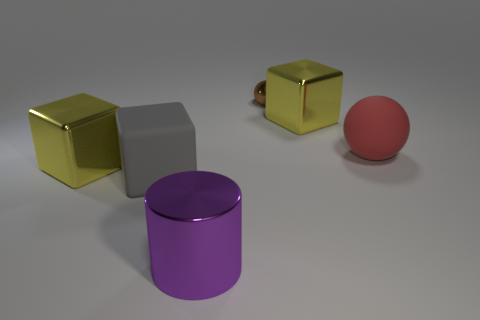Subtract all yellow blocks. How many were subtracted if there are1yellow blocks left? 1 Subtract all shiny blocks. How many blocks are left? 1 Add 2 large brown cylinders. How many objects exist? 8 Subtract all gray cubes. How many cubes are left? 2 Add 3 big red matte spheres. How many big red matte spheres are left? 4 Add 4 small balls. How many small balls exist? 5 Subtract 0 blue balls. How many objects are left? 6 Subtract all cylinders. How many objects are left? 5 Subtract all cyan cylinders. Subtract all blue spheres. How many cylinders are left? 1 Subtract all brown spheres. How many blue blocks are left? 0 